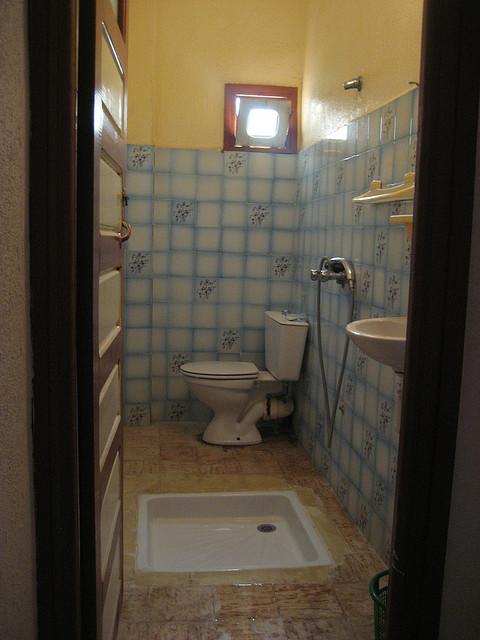What is the predominant color in the bathroom?
Short answer required. Blue. How dirty is this bathroom?
Short answer required. Not very dirty. Is the shower in an enclosure?
Concise answer only. No. Where is the shower head?
Write a very short answer. On wall. Does the bathroom door open from the inside of the bathroom or the outside of the bathroom?
Short answer required. Inside. 